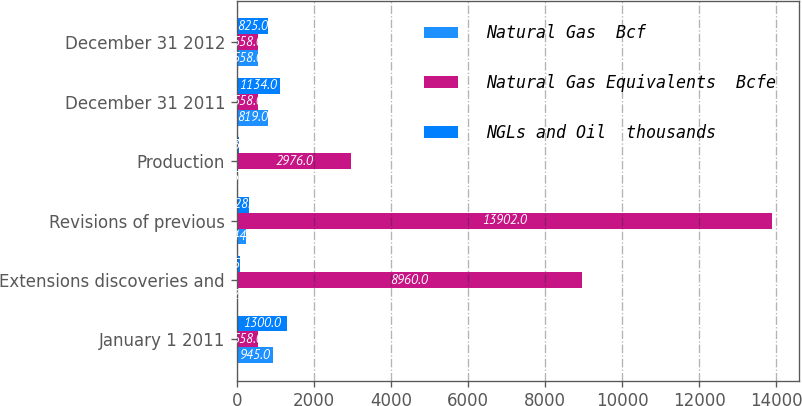Convert chart to OTSL. <chart><loc_0><loc_0><loc_500><loc_500><stacked_bar_chart><ecel><fcel>January 1 2011<fcel>Extensions discoveries and<fcel>Revisions of previous<fcel>Production<fcel>December 31 2011<fcel>December 31 2012<nl><fcel>Natural Gas  Bcf<fcel>945<fcel>22<fcel>244<fcel>45<fcel>819<fcel>558<nl><fcel>Natural Gas Equivalents  Bcfe<fcel>558<fcel>8960<fcel>13902<fcel>2976<fcel>558<fcel>558<nl><fcel>NGLs and Oil  thousands<fcel>1300<fcel>75<fcel>328<fcel>63<fcel>1134<fcel>825<nl></chart> 